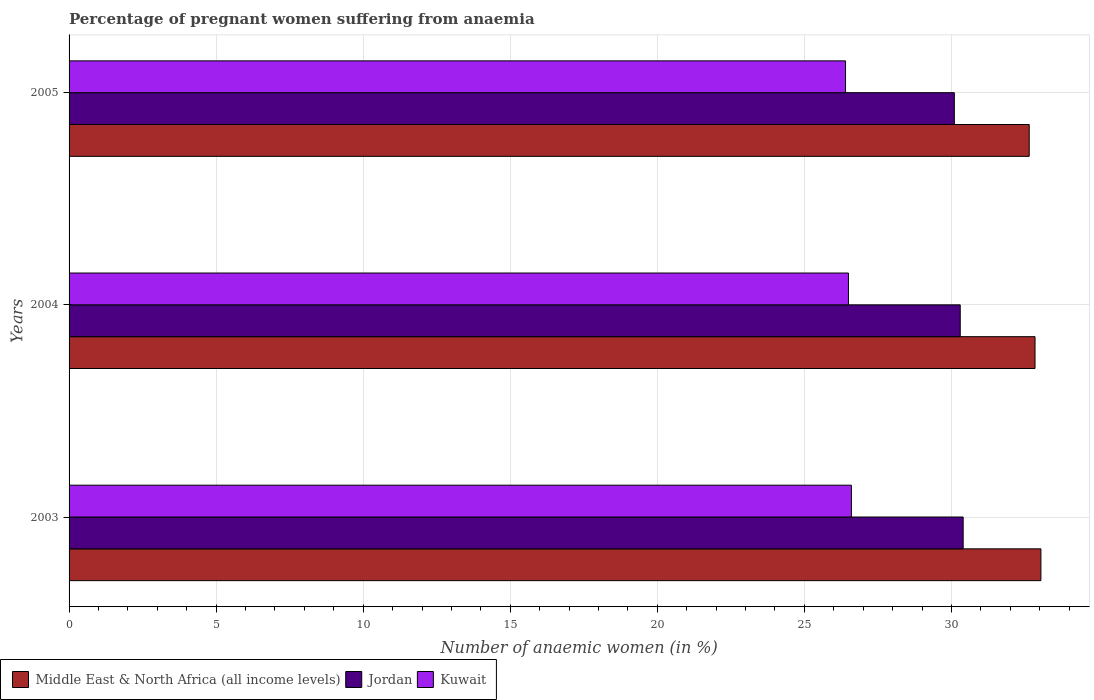Are the number of bars per tick equal to the number of legend labels?
Your answer should be very brief. Yes. Are the number of bars on each tick of the Y-axis equal?
Make the answer very short. Yes. How many bars are there on the 3rd tick from the bottom?
Ensure brevity in your answer.  3. What is the number of anaemic women in Middle East & North Africa (all income levels) in 2005?
Provide a short and direct response. 32.65. Across all years, what is the maximum number of anaemic women in Jordan?
Your response must be concise. 30.4. Across all years, what is the minimum number of anaemic women in Kuwait?
Make the answer very short. 26.4. In which year was the number of anaemic women in Jordan maximum?
Keep it short and to the point. 2003. In which year was the number of anaemic women in Kuwait minimum?
Offer a very short reply. 2005. What is the total number of anaemic women in Jordan in the graph?
Your answer should be compact. 90.8. What is the difference between the number of anaemic women in Middle East & North Africa (all income levels) in 2004 and that in 2005?
Your answer should be very brief. 0.2. What is the difference between the number of anaemic women in Jordan in 2004 and the number of anaemic women in Kuwait in 2005?
Provide a succinct answer. 3.9. What is the average number of anaemic women in Middle East & North Africa (all income levels) per year?
Your response must be concise. 32.84. In the year 2004, what is the difference between the number of anaemic women in Middle East & North Africa (all income levels) and number of anaemic women in Kuwait?
Provide a succinct answer. 6.34. What is the ratio of the number of anaemic women in Middle East & North Africa (all income levels) in 2004 to that in 2005?
Make the answer very short. 1.01. What is the difference between the highest and the second highest number of anaemic women in Jordan?
Provide a short and direct response. 0.1. What is the difference between the highest and the lowest number of anaemic women in Jordan?
Keep it short and to the point. 0.3. In how many years, is the number of anaemic women in Jordan greater than the average number of anaemic women in Jordan taken over all years?
Offer a terse response. 2. What does the 3rd bar from the top in 2004 represents?
Offer a very short reply. Middle East & North Africa (all income levels). What does the 1st bar from the bottom in 2003 represents?
Your answer should be compact. Middle East & North Africa (all income levels). How many years are there in the graph?
Ensure brevity in your answer.  3. Are the values on the major ticks of X-axis written in scientific E-notation?
Give a very brief answer. No. Does the graph contain any zero values?
Provide a short and direct response. No. Does the graph contain grids?
Offer a very short reply. Yes. How are the legend labels stacked?
Your answer should be compact. Horizontal. What is the title of the graph?
Ensure brevity in your answer.  Percentage of pregnant women suffering from anaemia. Does "Ghana" appear as one of the legend labels in the graph?
Ensure brevity in your answer.  No. What is the label or title of the X-axis?
Give a very brief answer. Number of anaemic women (in %). What is the label or title of the Y-axis?
Your answer should be very brief. Years. What is the Number of anaemic women (in %) in Middle East & North Africa (all income levels) in 2003?
Your response must be concise. 33.04. What is the Number of anaemic women (in %) in Jordan in 2003?
Make the answer very short. 30.4. What is the Number of anaemic women (in %) in Kuwait in 2003?
Keep it short and to the point. 26.6. What is the Number of anaemic women (in %) in Middle East & North Africa (all income levels) in 2004?
Ensure brevity in your answer.  32.84. What is the Number of anaemic women (in %) in Jordan in 2004?
Keep it short and to the point. 30.3. What is the Number of anaemic women (in %) in Middle East & North Africa (all income levels) in 2005?
Provide a succinct answer. 32.65. What is the Number of anaemic women (in %) in Jordan in 2005?
Ensure brevity in your answer.  30.1. What is the Number of anaemic women (in %) in Kuwait in 2005?
Your answer should be compact. 26.4. Across all years, what is the maximum Number of anaemic women (in %) of Middle East & North Africa (all income levels)?
Offer a very short reply. 33.04. Across all years, what is the maximum Number of anaemic women (in %) in Jordan?
Give a very brief answer. 30.4. Across all years, what is the maximum Number of anaemic women (in %) in Kuwait?
Ensure brevity in your answer.  26.6. Across all years, what is the minimum Number of anaemic women (in %) of Middle East & North Africa (all income levels)?
Provide a short and direct response. 32.65. Across all years, what is the minimum Number of anaemic women (in %) of Jordan?
Provide a short and direct response. 30.1. Across all years, what is the minimum Number of anaemic women (in %) of Kuwait?
Give a very brief answer. 26.4. What is the total Number of anaemic women (in %) in Middle East & North Africa (all income levels) in the graph?
Provide a short and direct response. 98.53. What is the total Number of anaemic women (in %) of Jordan in the graph?
Provide a short and direct response. 90.8. What is the total Number of anaemic women (in %) of Kuwait in the graph?
Your answer should be very brief. 79.5. What is the difference between the Number of anaemic women (in %) of Middle East & North Africa (all income levels) in 2003 and that in 2004?
Provide a short and direct response. 0.2. What is the difference between the Number of anaemic women (in %) of Jordan in 2003 and that in 2004?
Give a very brief answer. 0.1. What is the difference between the Number of anaemic women (in %) in Kuwait in 2003 and that in 2004?
Your answer should be compact. 0.1. What is the difference between the Number of anaemic women (in %) in Middle East & North Africa (all income levels) in 2003 and that in 2005?
Your response must be concise. 0.4. What is the difference between the Number of anaemic women (in %) of Kuwait in 2003 and that in 2005?
Make the answer very short. 0.2. What is the difference between the Number of anaemic women (in %) in Middle East & North Africa (all income levels) in 2004 and that in 2005?
Your answer should be very brief. 0.2. What is the difference between the Number of anaemic women (in %) of Jordan in 2004 and that in 2005?
Ensure brevity in your answer.  0.2. What is the difference between the Number of anaemic women (in %) of Kuwait in 2004 and that in 2005?
Provide a short and direct response. 0.1. What is the difference between the Number of anaemic women (in %) in Middle East & North Africa (all income levels) in 2003 and the Number of anaemic women (in %) in Jordan in 2004?
Offer a terse response. 2.74. What is the difference between the Number of anaemic women (in %) in Middle East & North Africa (all income levels) in 2003 and the Number of anaemic women (in %) in Kuwait in 2004?
Offer a very short reply. 6.54. What is the difference between the Number of anaemic women (in %) of Middle East & North Africa (all income levels) in 2003 and the Number of anaemic women (in %) of Jordan in 2005?
Offer a very short reply. 2.94. What is the difference between the Number of anaemic women (in %) of Middle East & North Africa (all income levels) in 2003 and the Number of anaemic women (in %) of Kuwait in 2005?
Make the answer very short. 6.64. What is the difference between the Number of anaemic women (in %) of Jordan in 2003 and the Number of anaemic women (in %) of Kuwait in 2005?
Offer a very short reply. 4. What is the difference between the Number of anaemic women (in %) of Middle East & North Africa (all income levels) in 2004 and the Number of anaemic women (in %) of Jordan in 2005?
Provide a succinct answer. 2.74. What is the difference between the Number of anaemic women (in %) of Middle East & North Africa (all income levels) in 2004 and the Number of anaemic women (in %) of Kuwait in 2005?
Your response must be concise. 6.44. What is the average Number of anaemic women (in %) in Middle East & North Africa (all income levels) per year?
Make the answer very short. 32.84. What is the average Number of anaemic women (in %) in Jordan per year?
Offer a terse response. 30.27. In the year 2003, what is the difference between the Number of anaemic women (in %) of Middle East & North Africa (all income levels) and Number of anaemic women (in %) of Jordan?
Provide a short and direct response. 2.64. In the year 2003, what is the difference between the Number of anaemic women (in %) of Middle East & North Africa (all income levels) and Number of anaemic women (in %) of Kuwait?
Keep it short and to the point. 6.44. In the year 2003, what is the difference between the Number of anaemic women (in %) of Jordan and Number of anaemic women (in %) of Kuwait?
Ensure brevity in your answer.  3.8. In the year 2004, what is the difference between the Number of anaemic women (in %) of Middle East & North Africa (all income levels) and Number of anaemic women (in %) of Jordan?
Provide a short and direct response. 2.54. In the year 2004, what is the difference between the Number of anaemic women (in %) in Middle East & North Africa (all income levels) and Number of anaemic women (in %) in Kuwait?
Provide a succinct answer. 6.34. In the year 2005, what is the difference between the Number of anaemic women (in %) in Middle East & North Africa (all income levels) and Number of anaemic women (in %) in Jordan?
Your response must be concise. 2.55. In the year 2005, what is the difference between the Number of anaemic women (in %) of Middle East & North Africa (all income levels) and Number of anaemic women (in %) of Kuwait?
Keep it short and to the point. 6.25. What is the ratio of the Number of anaemic women (in %) of Middle East & North Africa (all income levels) in 2003 to that in 2004?
Provide a succinct answer. 1.01. What is the ratio of the Number of anaemic women (in %) in Jordan in 2003 to that in 2004?
Offer a very short reply. 1. What is the ratio of the Number of anaemic women (in %) in Middle East & North Africa (all income levels) in 2003 to that in 2005?
Offer a terse response. 1.01. What is the ratio of the Number of anaemic women (in %) of Kuwait in 2003 to that in 2005?
Your response must be concise. 1.01. What is the ratio of the Number of anaemic women (in %) in Middle East & North Africa (all income levels) in 2004 to that in 2005?
Your answer should be very brief. 1.01. What is the ratio of the Number of anaemic women (in %) of Jordan in 2004 to that in 2005?
Your response must be concise. 1.01. What is the difference between the highest and the second highest Number of anaemic women (in %) in Middle East & North Africa (all income levels)?
Offer a very short reply. 0.2. What is the difference between the highest and the lowest Number of anaemic women (in %) in Middle East & North Africa (all income levels)?
Offer a terse response. 0.4. What is the difference between the highest and the lowest Number of anaemic women (in %) of Jordan?
Keep it short and to the point. 0.3. What is the difference between the highest and the lowest Number of anaemic women (in %) of Kuwait?
Keep it short and to the point. 0.2. 